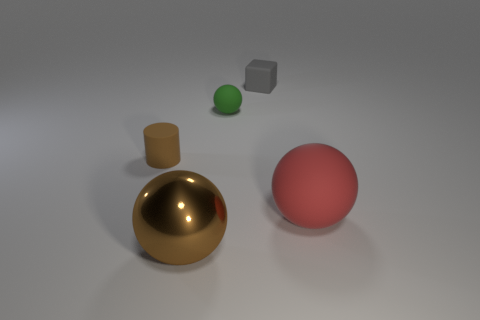Add 3 yellow metal objects. How many objects exist? 8 Subtract all cubes. How many objects are left? 4 Subtract 0 blue cubes. How many objects are left? 5 Subtract all large red blocks. Subtract all tiny brown cylinders. How many objects are left? 4 Add 5 small balls. How many small balls are left? 6 Add 4 matte things. How many matte things exist? 8 